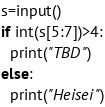Convert code to text. <code><loc_0><loc_0><loc_500><loc_500><_Python_>s=input()
if int(s[5:7])>4:
  print("TBD")
else:
  print("Heisei")</code> 